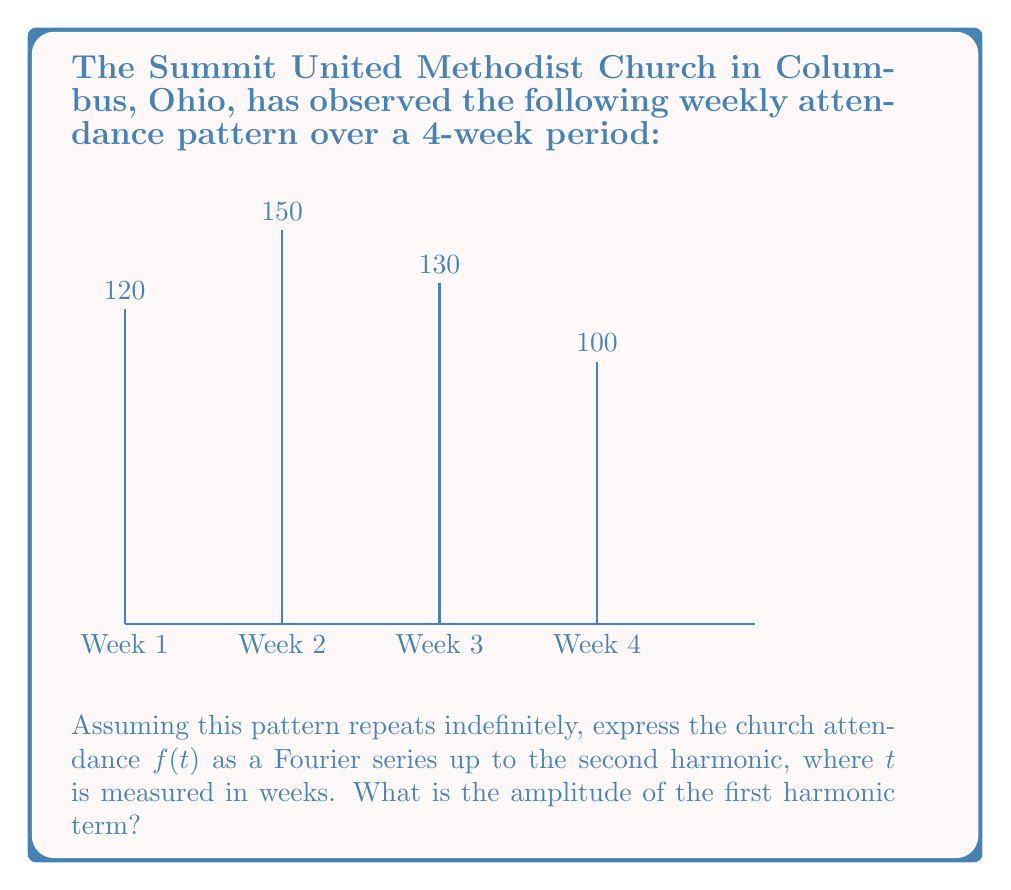Give your solution to this math problem. Let's approach this step-by-step:

1) First, we need to find the average attendance $a_0$:
   $$a_0 = \frac{1}{4}(120 + 150 + 130 + 100) = 125$$

2) The fundamental period $T$ is 4 weeks, so $\omega = \frac{2\pi}{T} = \frac{\pi}{2}$

3) For the Fourier series, we need to calculate $a_n$ and $b_n$ coefficients:

   $$a_n = \frac{2}{T}\int_0^T f(t)\cos(n\omega t)dt$$
   $$b_n = \frac{2}{T}\int_0^T f(t)\sin(n\omega t)dt$$

4) For discrete data, these integrals become sums:

   $$a_n = \frac{1}{2}\sum_{k=0}^3 f(k)\cos(\frac{n\pi k}{2})$$
   $$b_n = \frac{1}{2}\sum_{k=0}^3 f(k)\sin(\frac{n\pi k}{2})$$

5) Calculating $a_1$:
   $$a_1 = \frac{1}{2}[120\cos(0) + 150\cos(\frac{\pi}{2}) + 130\cos(\pi) + 100\cos(\frac{3\pi}{2})] = -5$$

6) Calculating $b_1$:
   $$b_1 = \frac{1}{2}[120\sin(0) + 150\sin(\frac{\pi}{2}) + 130\sin(\pi) + 100\sin(\frac{3\pi}{2})] = 25$$

7) The amplitude of the first harmonic is $\sqrt{a_1^2 + b_1^2}$:
   $$\sqrt{(-5)^2 + 25^2} = \sqrt{25 + 625} = \sqrt{650} = 5\sqrt{26}$$

Therefore, the amplitude of the first harmonic term is $5\sqrt{26}$.
Answer: $5\sqrt{26}$ 